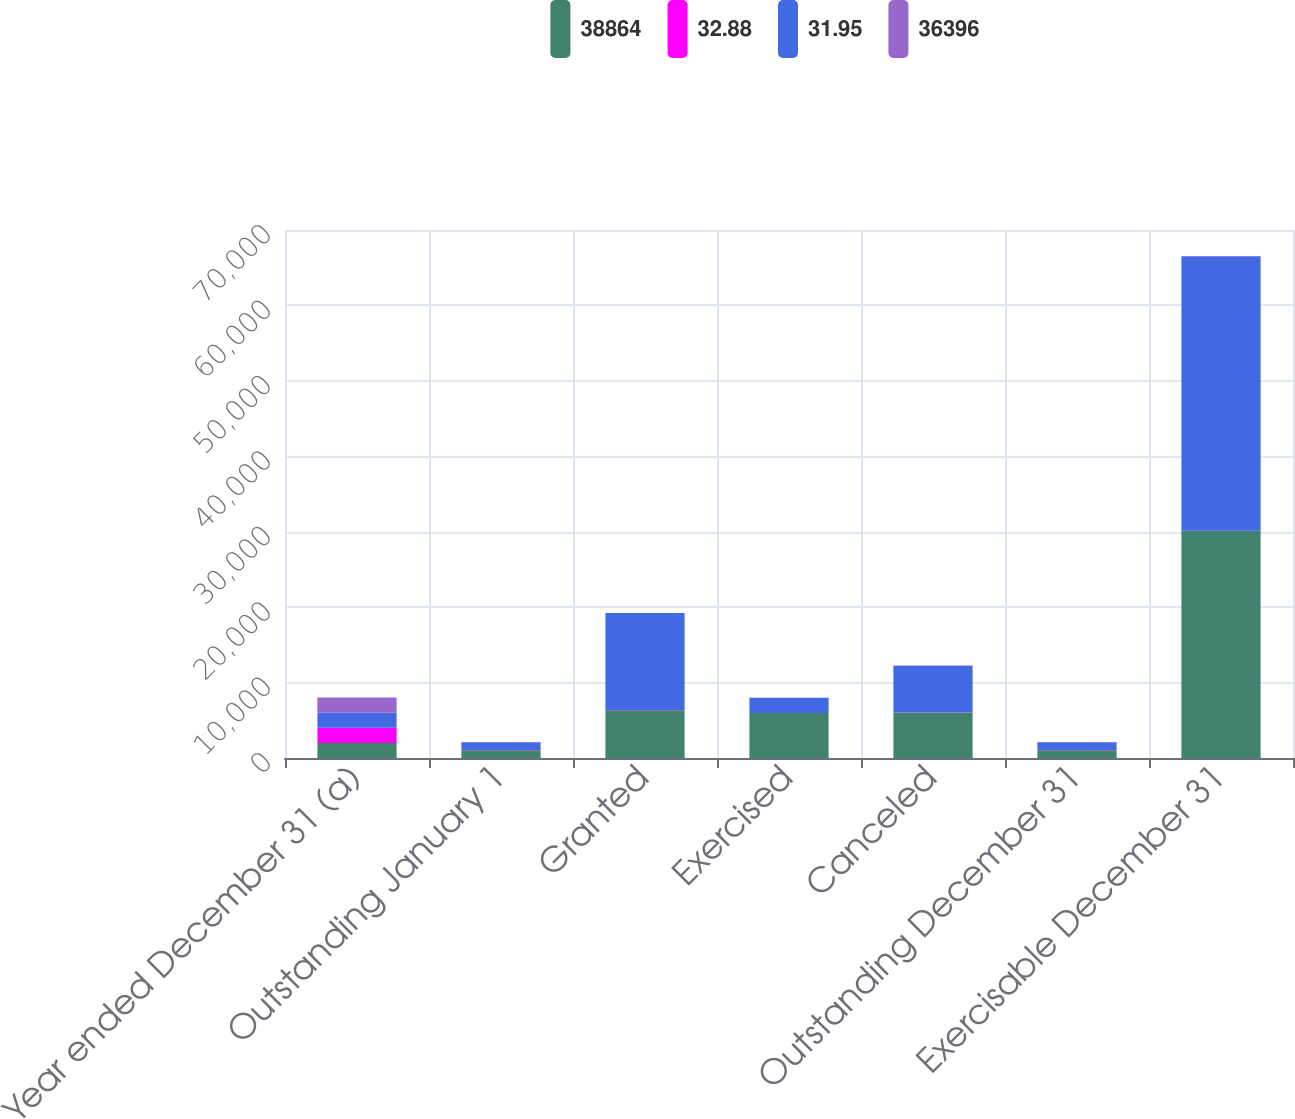Convert chart. <chart><loc_0><loc_0><loc_500><loc_500><stacked_bar_chart><ecel><fcel>Year ended December 31 (a)<fcel>Outstanding January 1<fcel>Granted<fcel>Exercised<fcel>Canceled<fcel>Outstanding December 31<fcel>Exercisable December 31<nl><fcel>38864<fcel>2004<fcel>1021.81<fcel>6321<fcel>5960<fcel>5999<fcel>1021.81<fcel>30082<nl><fcel>32.88<fcel>2004<fcel>39.11<fcel>39.96<fcel>15.26<fcel>39.18<fcel>40.42<fcel>36.33<nl><fcel>31.95<fcel>2003<fcel>1021.81<fcel>12846<fcel>2007<fcel>6172<fcel>1021.81<fcel>36396<nl><fcel>36396<fcel>2003<fcel>40.62<fcel>21.87<fcel>13.67<fcel>37.8<fcel>39.11<fcel>32.88<nl></chart> 